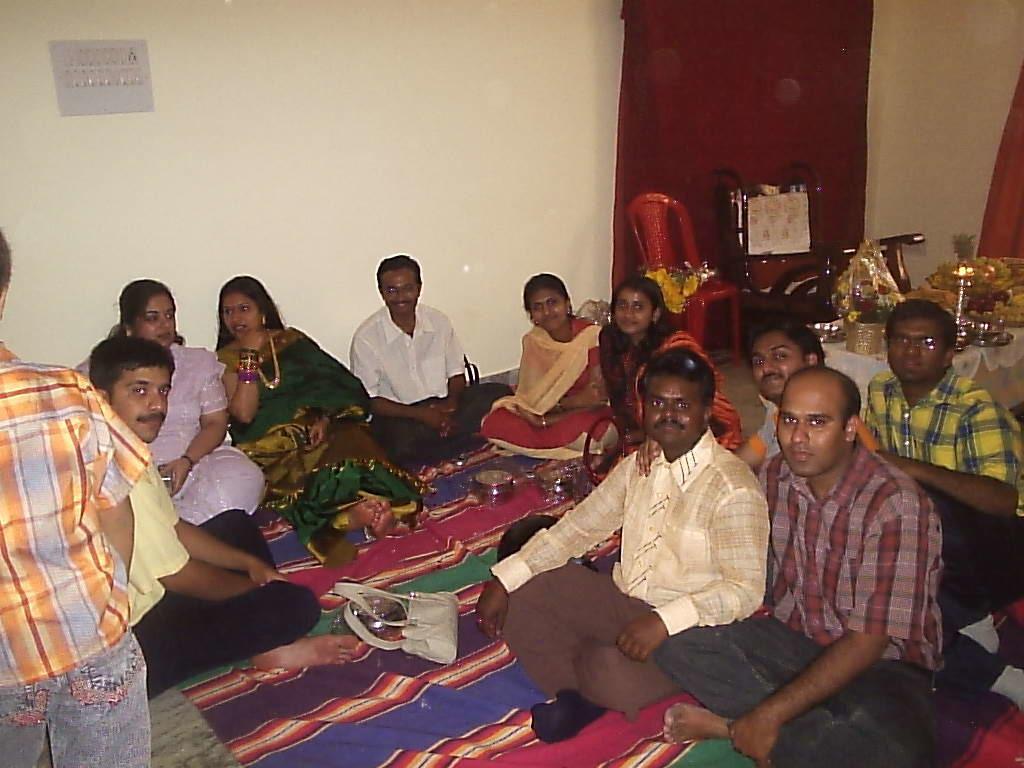In one or two sentences, can you explain what this image depicts? In this picture there are people those who are sitting on the floor right and left side of the image, there is a chair and flowers in the background area of the image, there is a switch board in the top left side of the image. 